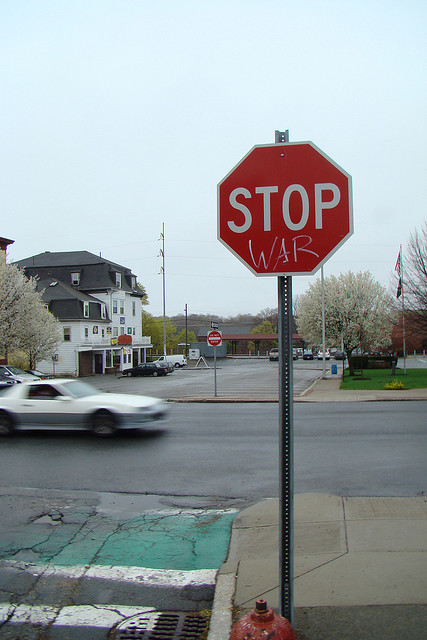<image>What song is the sign referencing? I am not sure. The sign may be referring to the song 'war' or 'stop war'. What song is the sign referencing? I don't know what song the sign is referencing. It can be any of the mentioned songs: 'war', 'stop war', 'war what is it good for', or 'war song'. 